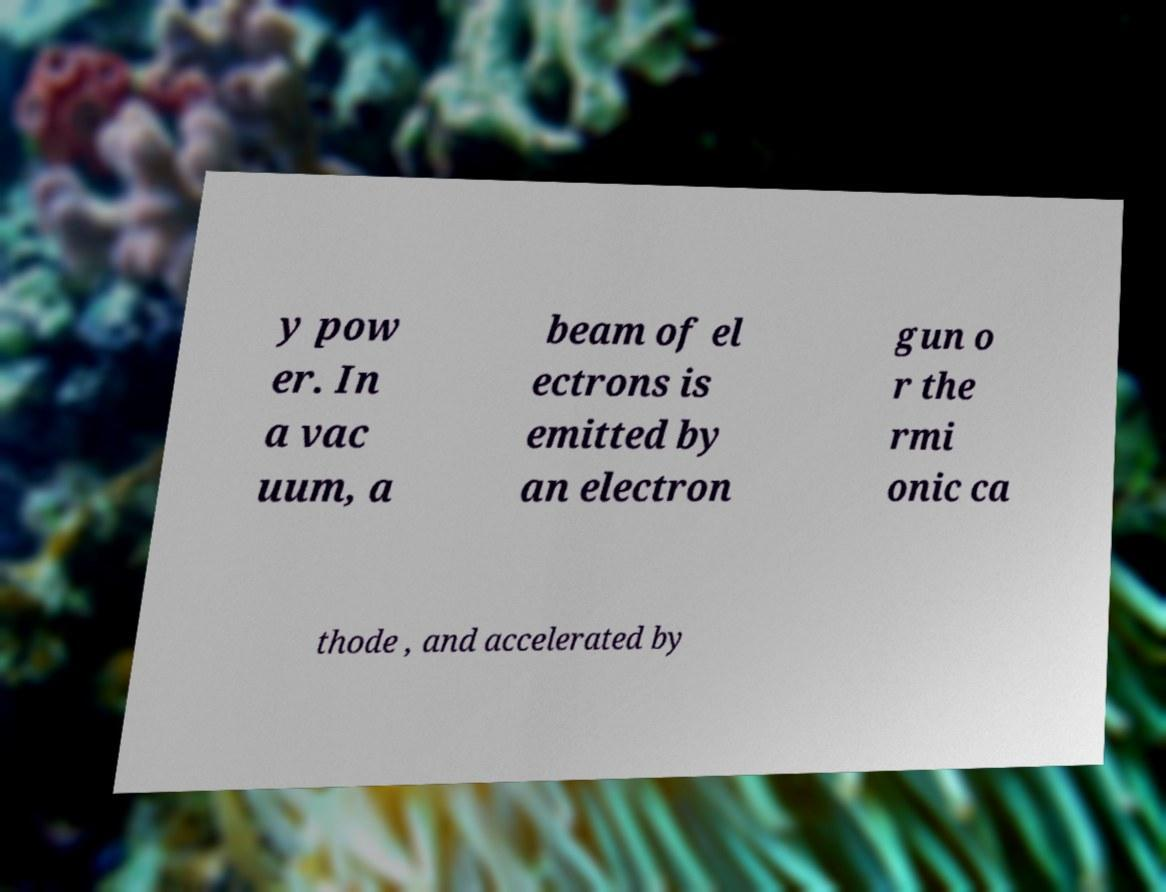Could you assist in decoding the text presented in this image and type it out clearly? y pow er. In a vac uum, a beam of el ectrons is emitted by an electron gun o r the rmi onic ca thode , and accelerated by 